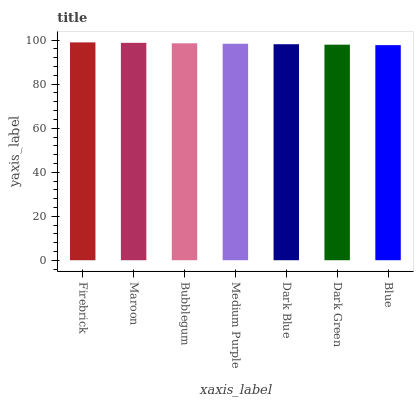Is Maroon the minimum?
Answer yes or no. No. Is Maroon the maximum?
Answer yes or no. No. Is Firebrick greater than Maroon?
Answer yes or no. Yes. Is Maroon less than Firebrick?
Answer yes or no. Yes. Is Maroon greater than Firebrick?
Answer yes or no. No. Is Firebrick less than Maroon?
Answer yes or no. No. Is Medium Purple the high median?
Answer yes or no. Yes. Is Medium Purple the low median?
Answer yes or no. Yes. Is Dark Green the high median?
Answer yes or no. No. Is Bubblegum the low median?
Answer yes or no. No. 